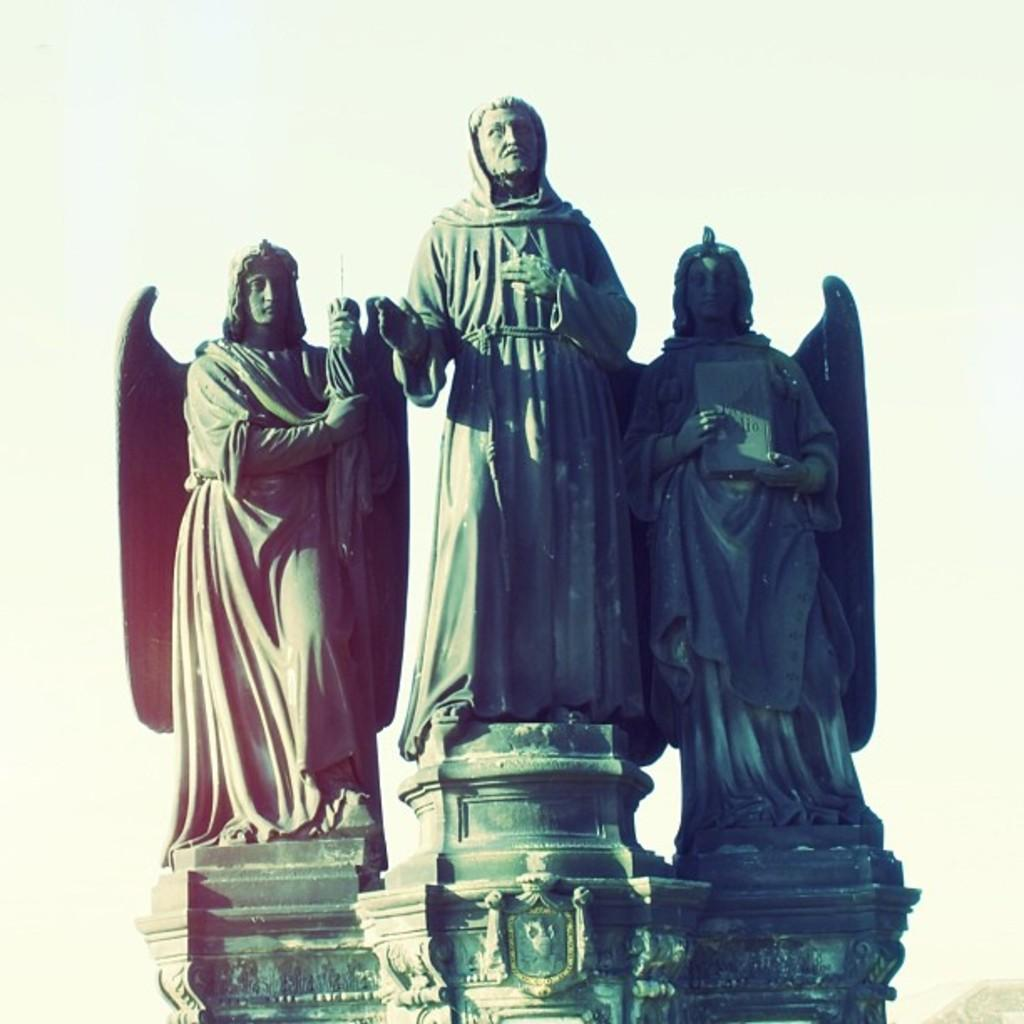What is the main subject of the image? There is a statue in the image. What does the statue depict? The statue depicts three persons standing. What is the color of the statue? The statue is black in color. What can be seen in the background of the image? The background of the image is plain. What time of day is it in the image, and what is the secretary doing? The time of day and the presence of a secretary are not mentioned in the image, so we cannot answer these questions. 